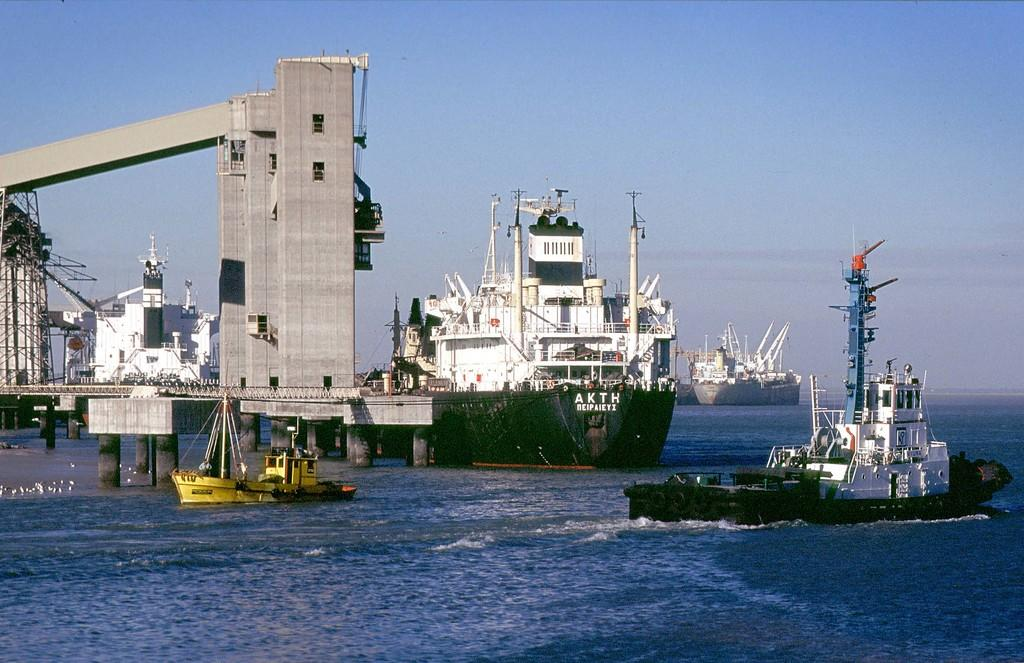Provide a one-sentence caption for the provided image. A huge freighter sits in the water with AKTH on its front section. 